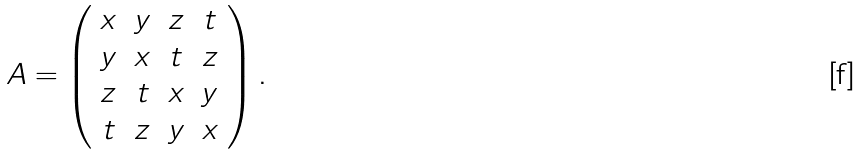Convert formula to latex. <formula><loc_0><loc_0><loc_500><loc_500>A = \left ( \begin{array} { c c c c } x & y & z & t \\ y & x & t & z \\ z & t & x & y \\ t & z & y & x \end{array} \right ) .</formula> 